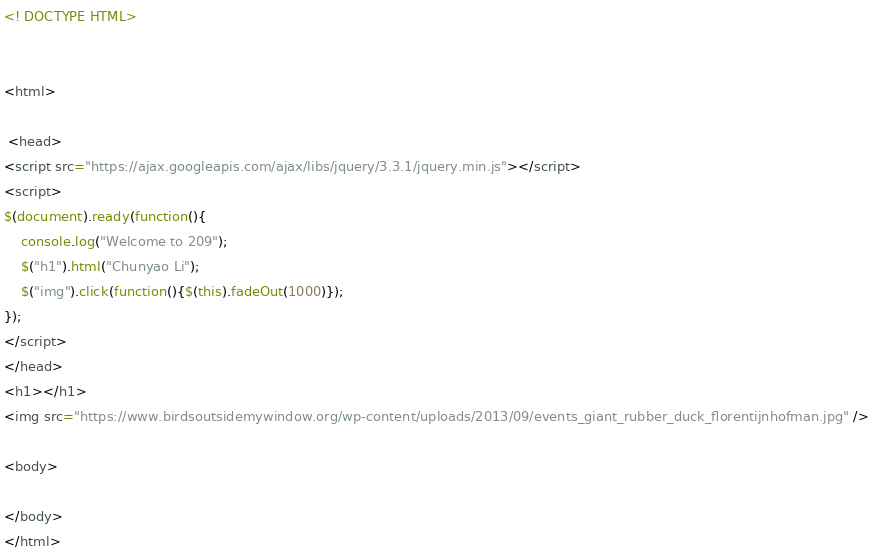<code> <loc_0><loc_0><loc_500><loc_500><_HTML_><! DOCTYPE HTML>


<html>

 <head>
<script src="https://ajax.googleapis.com/ajax/libs/jquery/3.3.1/jquery.min.js"></script>
<script>
$(document).ready(function(){
	console.log("Welcome to 209");
	$("h1").html("Chunyao Li");
	$("img").click(function(){$(this).fadeOut(1000)});
});
</script>
</head> 
<h1></h1>
<img src="https://www.birdsoutsidemywindow.org/wp-content/uploads/2013/09/events_giant_rubber_duck_florentijnhofman.jpg" />

<body>

</body>
</html></code> 